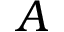<formula> <loc_0><loc_0><loc_500><loc_500>A</formula> 